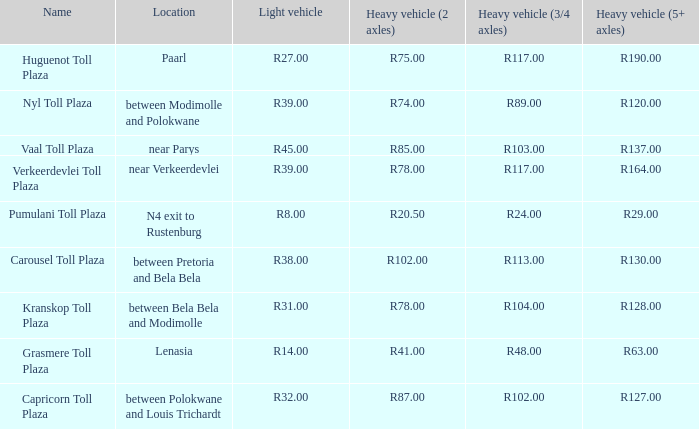What is the toll for heavy vehicles with 3/4 axles at Verkeerdevlei toll plaza? R117.00. 